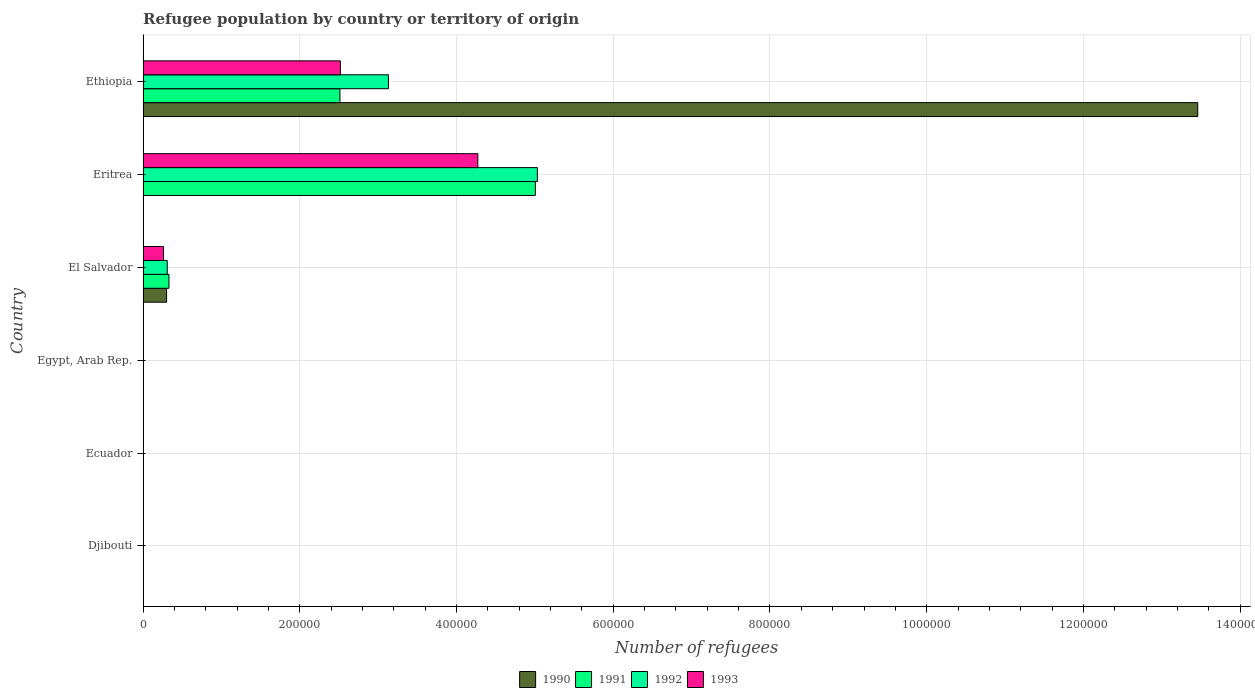Are the number of bars per tick equal to the number of legend labels?
Your answer should be very brief. Yes. Are the number of bars on each tick of the Y-axis equal?
Provide a short and direct response. Yes. How many bars are there on the 3rd tick from the top?
Offer a terse response. 4. How many bars are there on the 4th tick from the bottom?
Offer a terse response. 4. What is the label of the 1st group of bars from the top?
Offer a very short reply. Ethiopia. What is the number of refugees in 1992 in Egypt, Arab Rep.?
Provide a short and direct response. 209. Across all countries, what is the maximum number of refugees in 1990?
Make the answer very short. 1.35e+06. In which country was the number of refugees in 1993 maximum?
Your answer should be compact. Eritrea. In which country was the number of refugees in 1991 minimum?
Keep it short and to the point. Djibouti. What is the total number of refugees in 1993 in the graph?
Offer a terse response. 7.06e+05. What is the difference between the number of refugees in 1991 in Eritrea and that in Ethiopia?
Provide a succinct answer. 2.49e+05. What is the difference between the number of refugees in 1993 in Ecuador and the number of refugees in 1991 in El Salvador?
Your response must be concise. -3.30e+04. What is the average number of refugees in 1993 per country?
Offer a terse response. 1.18e+05. What is the difference between the number of refugees in 1990 and number of refugees in 1992 in El Salvador?
Make the answer very short. -836. What is the ratio of the number of refugees in 1993 in Egypt, Arab Rep. to that in El Salvador?
Make the answer very short. 0.01. What is the difference between the highest and the second highest number of refugees in 1992?
Offer a very short reply. 1.90e+05. What is the difference between the highest and the lowest number of refugees in 1992?
Provide a succinct answer. 5.03e+05. Is the sum of the number of refugees in 1992 in Egypt, Arab Rep. and Eritrea greater than the maximum number of refugees in 1990 across all countries?
Ensure brevity in your answer.  No. Is it the case that in every country, the sum of the number of refugees in 1993 and number of refugees in 1990 is greater than the sum of number of refugees in 1992 and number of refugees in 1991?
Your answer should be very brief. No. Is it the case that in every country, the sum of the number of refugees in 1993 and number of refugees in 1991 is greater than the number of refugees in 1990?
Offer a terse response. No. How many bars are there?
Provide a short and direct response. 24. Are all the bars in the graph horizontal?
Give a very brief answer. Yes. What is the difference between two consecutive major ticks on the X-axis?
Your answer should be very brief. 2.00e+05. Are the values on the major ticks of X-axis written in scientific E-notation?
Make the answer very short. No. Does the graph contain any zero values?
Ensure brevity in your answer.  No. Does the graph contain grids?
Provide a succinct answer. Yes. How many legend labels are there?
Give a very brief answer. 4. What is the title of the graph?
Provide a short and direct response. Refugee population by country or territory of origin. Does "2006" appear as one of the legend labels in the graph?
Provide a succinct answer. No. What is the label or title of the X-axis?
Ensure brevity in your answer.  Number of refugees. What is the label or title of the Y-axis?
Provide a short and direct response. Country. What is the Number of refugees of 1991 in Djibouti?
Make the answer very short. 10. What is the Number of refugees in 1992 in Ecuador?
Offer a terse response. 40. What is the Number of refugees of 1991 in Egypt, Arab Rep.?
Provide a succinct answer. 97. What is the Number of refugees of 1992 in Egypt, Arab Rep.?
Offer a very short reply. 209. What is the Number of refugees of 1993 in Egypt, Arab Rep.?
Your response must be concise. 258. What is the Number of refugees of 1990 in El Salvador?
Give a very brief answer. 3.00e+04. What is the Number of refugees of 1991 in El Salvador?
Offer a very short reply. 3.30e+04. What is the Number of refugees of 1992 in El Salvador?
Your answer should be very brief. 3.09e+04. What is the Number of refugees in 1993 in El Salvador?
Make the answer very short. 2.61e+04. What is the Number of refugees of 1990 in Eritrea?
Offer a terse response. 43. What is the Number of refugees of 1991 in Eritrea?
Provide a succinct answer. 5.01e+05. What is the Number of refugees of 1992 in Eritrea?
Make the answer very short. 5.03e+05. What is the Number of refugees in 1993 in Eritrea?
Your response must be concise. 4.27e+05. What is the Number of refugees in 1990 in Ethiopia?
Offer a terse response. 1.35e+06. What is the Number of refugees of 1991 in Ethiopia?
Your answer should be compact. 2.51e+05. What is the Number of refugees of 1992 in Ethiopia?
Your answer should be compact. 3.13e+05. What is the Number of refugees in 1993 in Ethiopia?
Provide a succinct answer. 2.52e+05. Across all countries, what is the maximum Number of refugees in 1990?
Your answer should be compact. 1.35e+06. Across all countries, what is the maximum Number of refugees in 1991?
Make the answer very short. 5.01e+05. Across all countries, what is the maximum Number of refugees of 1992?
Keep it short and to the point. 5.03e+05. Across all countries, what is the maximum Number of refugees in 1993?
Your answer should be compact. 4.27e+05. Across all countries, what is the minimum Number of refugees in 1990?
Provide a succinct answer. 3. Across all countries, what is the minimum Number of refugees of 1992?
Give a very brief answer. 11. Across all countries, what is the minimum Number of refugees in 1993?
Your response must be concise. 38. What is the total Number of refugees of 1990 in the graph?
Make the answer very short. 1.38e+06. What is the total Number of refugees of 1991 in the graph?
Ensure brevity in your answer.  7.85e+05. What is the total Number of refugees in 1992 in the graph?
Give a very brief answer. 8.47e+05. What is the total Number of refugees of 1993 in the graph?
Keep it short and to the point. 7.06e+05. What is the difference between the Number of refugees of 1990 in Djibouti and that in Ecuador?
Provide a short and direct response. 2. What is the difference between the Number of refugees of 1991 in Djibouti and that in Ecuador?
Your response must be concise. -17. What is the difference between the Number of refugees of 1992 in Djibouti and that in Ecuador?
Keep it short and to the point. -29. What is the difference between the Number of refugees in 1990 in Djibouti and that in Egypt, Arab Rep.?
Keep it short and to the point. -43. What is the difference between the Number of refugees in 1991 in Djibouti and that in Egypt, Arab Rep.?
Keep it short and to the point. -87. What is the difference between the Number of refugees of 1992 in Djibouti and that in Egypt, Arab Rep.?
Keep it short and to the point. -198. What is the difference between the Number of refugees in 1993 in Djibouti and that in Egypt, Arab Rep.?
Your answer should be compact. -220. What is the difference between the Number of refugees in 1990 in Djibouti and that in El Salvador?
Give a very brief answer. -3.00e+04. What is the difference between the Number of refugees in 1991 in Djibouti and that in El Salvador?
Keep it short and to the point. -3.30e+04. What is the difference between the Number of refugees of 1992 in Djibouti and that in El Salvador?
Ensure brevity in your answer.  -3.08e+04. What is the difference between the Number of refugees in 1993 in Djibouti and that in El Salvador?
Provide a short and direct response. -2.61e+04. What is the difference between the Number of refugees in 1990 in Djibouti and that in Eritrea?
Offer a very short reply. -38. What is the difference between the Number of refugees in 1991 in Djibouti and that in Eritrea?
Keep it short and to the point. -5.01e+05. What is the difference between the Number of refugees in 1992 in Djibouti and that in Eritrea?
Ensure brevity in your answer.  -5.03e+05. What is the difference between the Number of refugees in 1993 in Djibouti and that in Eritrea?
Give a very brief answer. -4.27e+05. What is the difference between the Number of refugees of 1990 in Djibouti and that in Ethiopia?
Your response must be concise. -1.35e+06. What is the difference between the Number of refugees in 1991 in Djibouti and that in Ethiopia?
Ensure brevity in your answer.  -2.51e+05. What is the difference between the Number of refugees in 1992 in Djibouti and that in Ethiopia?
Give a very brief answer. -3.13e+05. What is the difference between the Number of refugees in 1993 in Djibouti and that in Ethiopia?
Offer a very short reply. -2.52e+05. What is the difference between the Number of refugees in 1990 in Ecuador and that in Egypt, Arab Rep.?
Your response must be concise. -45. What is the difference between the Number of refugees of 1991 in Ecuador and that in Egypt, Arab Rep.?
Give a very brief answer. -70. What is the difference between the Number of refugees of 1992 in Ecuador and that in Egypt, Arab Rep.?
Your answer should be compact. -169. What is the difference between the Number of refugees in 1993 in Ecuador and that in Egypt, Arab Rep.?
Your answer should be very brief. -211. What is the difference between the Number of refugees of 1990 in Ecuador and that in El Salvador?
Keep it short and to the point. -3.00e+04. What is the difference between the Number of refugees in 1991 in Ecuador and that in El Salvador?
Offer a very short reply. -3.30e+04. What is the difference between the Number of refugees of 1992 in Ecuador and that in El Salvador?
Ensure brevity in your answer.  -3.08e+04. What is the difference between the Number of refugees of 1993 in Ecuador and that in El Salvador?
Provide a short and direct response. -2.61e+04. What is the difference between the Number of refugees in 1990 in Ecuador and that in Eritrea?
Provide a short and direct response. -40. What is the difference between the Number of refugees of 1991 in Ecuador and that in Eritrea?
Give a very brief answer. -5.01e+05. What is the difference between the Number of refugees in 1992 in Ecuador and that in Eritrea?
Your answer should be very brief. -5.03e+05. What is the difference between the Number of refugees of 1993 in Ecuador and that in Eritrea?
Provide a short and direct response. -4.27e+05. What is the difference between the Number of refugees of 1990 in Ecuador and that in Ethiopia?
Provide a short and direct response. -1.35e+06. What is the difference between the Number of refugees in 1991 in Ecuador and that in Ethiopia?
Keep it short and to the point. -2.51e+05. What is the difference between the Number of refugees in 1992 in Ecuador and that in Ethiopia?
Give a very brief answer. -3.13e+05. What is the difference between the Number of refugees of 1993 in Ecuador and that in Ethiopia?
Your response must be concise. -2.52e+05. What is the difference between the Number of refugees in 1990 in Egypt, Arab Rep. and that in El Salvador?
Provide a succinct answer. -3.00e+04. What is the difference between the Number of refugees of 1991 in Egypt, Arab Rep. and that in El Salvador?
Offer a very short reply. -3.30e+04. What is the difference between the Number of refugees in 1992 in Egypt, Arab Rep. and that in El Salvador?
Provide a succinct answer. -3.06e+04. What is the difference between the Number of refugees in 1993 in Egypt, Arab Rep. and that in El Salvador?
Offer a terse response. -2.59e+04. What is the difference between the Number of refugees in 1991 in Egypt, Arab Rep. and that in Eritrea?
Your response must be concise. -5.01e+05. What is the difference between the Number of refugees of 1992 in Egypt, Arab Rep. and that in Eritrea?
Give a very brief answer. -5.03e+05. What is the difference between the Number of refugees of 1993 in Egypt, Arab Rep. and that in Eritrea?
Provide a succinct answer. -4.27e+05. What is the difference between the Number of refugees of 1990 in Egypt, Arab Rep. and that in Ethiopia?
Provide a short and direct response. -1.35e+06. What is the difference between the Number of refugees of 1991 in Egypt, Arab Rep. and that in Ethiopia?
Ensure brevity in your answer.  -2.51e+05. What is the difference between the Number of refugees of 1992 in Egypt, Arab Rep. and that in Ethiopia?
Provide a succinct answer. -3.13e+05. What is the difference between the Number of refugees of 1993 in Egypt, Arab Rep. and that in Ethiopia?
Provide a short and direct response. -2.52e+05. What is the difference between the Number of refugees in 1990 in El Salvador and that in Eritrea?
Make the answer very short. 3.00e+04. What is the difference between the Number of refugees of 1991 in El Salvador and that in Eritrea?
Keep it short and to the point. -4.68e+05. What is the difference between the Number of refugees in 1992 in El Salvador and that in Eritrea?
Provide a short and direct response. -4.72e+05. What is the difference between the Number of refugees in 1993 in El Salvador and that in Eritrea?
Ensure brevity in your answer.  -4.01e+05. What is the difference between the Number of refugees of 1990 in El Salvador and that in Ethiopia?
Give a very brief answer. -1.32e+06. What is the difference between the Number of refugees of 1991 in El Salvador and that in Ethiopia?
Provide a succinct answer. -2.18e+05. What is the difference between the Number of refugees of 1992 in El Salvador and that in Ethiopia?
Provide a short and direct response. -2.82e+05. What is the difference between the Number of refugees of 1993 in El Salvador and that in Ethiopia?
Your response must be concise. -2.26e+05. What is the difference between the Number of refugees of 1990 in Eritrea and that in Ethiopia?
Offer a terse response. -1.35e+06. What is the difference between the Number of refugees of 1991 in Eritrea and that in Ethiopia?
Offer a terse response. 2.49e+05. What is the difference between the Number of refugees in 1992 in Eritrea and that in Ethiopia?
Ensure brevity in your answer.  1.90e+05. What is the difference between the Number of refugees of 1993 in Eritrea and that in Ethiopia?
Your response must be concise. 1.75e+05. What is the difference between the Number of refugees in 1990 in Djibouti and the Number of refugees in 1992 in Ecuador?
Offer a terse response. -35. What is the difference between the Number of refugees of 1990 in Djibouti and the Number of refugees of 1993 in Ecuador?
Your answer should be compact. -42. What is the difference between the Number of refugees in 1991 in Djibouti and the Number of refugees in 1992 in Ecuador?
Give a very brief answer. -30. What is the difference between the Number of refugees of 1991 in Djibouti and the Number of refugees of 1993 in Ecuador?
Provide a short and direct response. -37. What is the difference between the Number of refugees of 1992 in Djibouti and the Number of refugees of 1993 in Ecuador?
Your answer should be very brief. -36. What is the difference between the Number of refugees of 1990 in Djibouti and the Number of refugees of 1991 in Egypt, Arab Rep.?
Make the answer very short. -92. What is the difference between the Number of refugees of 1990 in Djibouti and the Number of refugees of 1992 in Egypt, Arab Rep.?
Your answer should be very brief. -204. What is the difference between the Number of refugees of 1990 in Djibouti and the Number of refugees of 1993 in Egypt, Arab Rep.?
Your answer should be compact. -253. What is the difference between the Number of refugees of 1991 in Djibouti and the Number of refugees of 1992 in Egypt, Arab Rep.?
Offer a very short reply. -199. What is the difference between the Number of refugees in 1991 in Djibouti and the Number of refugees in 1993 in Egypt, Arab Rep.?
Offer a very short reply. -248. What is the difference between the Number of refugees in 1992 in Djibouti and the Number of refugees in 1993 in Egypt, Arab Rep.?
Give a very brief answer. -247. What is the difference between the Number of refugees in 1990 in Djibouti and the Number of refugees in 1991 in El Salvador?
Provide a short and direct response. -3.30e+04. What is the difference between the Number of refugees in 1990 in Djibouti and the Number of refugees in 1992 in El Salvador?
Your answer should be very brief. -3.08e+04. What is the difference between the Number of refugees in 1990 in Djibouti and the Number of refugees in 1993 in El Salvador?
Your answer should be compact. -2.61e+04. What is the difference between the Number of refugees of 1991 in Djibouti and the Number of refugees of 1992 in El Salvador?
Your response must be concise. -3.08e+04. What is the difference between the Number of refugees in 1991 in Djibouti and the Number of refugees in 1993 in El Salvador?
Give a very brief answer. -2.61e+04. What is the difference between the Number of refugees in 1992 in Djibouti and the Number of refugees in 1993 in El Salvador?
Give a very brief answer. -2.61e+04. What is the difference between the Number of refugees in 1990 in Djibouti and the Number of refugees in 1991 in Eritrea?
Your answer should be compact. -5.01e+05. What is the difference between the Number of refugees in 1990 in Djibouti and the Number of refugees in 1992 in Eritrea?
Keep it short and to the point. -5.03e+05. What is the difference between the Number of refugees of 1990 in Djibouti and the Number of refugees of 1993 in Eritrea?
Make the answer very short. -4.27e+05. What is the difference between the Number of refugees in 1991 in Djibouti and the Number of refugees in 1992 in Eritrea?
Provide a short and direct response. -5.03e+05. What is the difference between the Number of refugees in 1991 in Djibouti and the Number of refugees in 1993 in Eritrea?
Your answer should be compact. -4.27e+05. What is the difference between the Number of refugees in 1992 in Djibouti and the Number of refugees in 1993 in Eritrea?
Provide a succinct answer. -4.27e+05. What is the difference between the Number of refugees of 1990 in Djibouti and the Number of refugees of 1991 in Ethiopia?
Your response must be concise. -2.51e+05. What is the difference between the Number of refugees in 1990 in Djibouti and the Number of refugees in 1992 in Ethiopia?
Keep it short and to the point. -3.13e+05. What is the difference between the Number of refugees of 1990 in Djibouti and the Number of refugees of 1993 in Ethiopia?
Give a very brief answer. -2.52e+05. What is the difference between the Number of refugees of 1991 in Djibouti and the Number of refugees of 1992 in Ethiopia?
Offer a terse response. -3.13e+05. What is the difference between the Number of refugees of 1991 in Djibouti and the Number of refugees of 1993 in Ethiopia?
Make the answer very short. -2.52e+05. What is the difference between the Number of refugees of 1992 in Djibouti and the Number of refugees of 1993 in Ethiopia?
Ensure brevity in your answer.  -2.52e+05. What is the difference between the Number of refugees in 1990 in Ecuador and the Number of refugees in 1991 in Egypt, Arab Rep.?
Provide a short and direct response. -94. What is the difference between the Number of refugees in 1990 in Ecuador and the Number of refugees in 1992 in Egypt, Arab Rep.?
Your answer should be compact. -206. What is the difference between the Number of refugees in 1990 in Ecuador and the Number of refugees in 1993 in Egypt, Arab Rep.?
Your answer should be compact. -255. What is the difference between the Number of refugees of 1991 in Ecuador and the Number of refugees of 1992 in Egypt, Arab Rep.?
Your answer should be very brief. -182. What is the difference between the Number of refugees in 1991 in Ecuador and the Number of refugees in 1993 in Egypt, Arab Rep.?
Make the answer very short. -231. What is the difference between the Number of refugees of 1992 in Ecuador and the Number of refugees of 1993 in Egypt, Arab Rep.?
Your response must be concise. -218. What is the difference between the Number of refugees of 1990 in Ecuador and the Number of refugees of 1991 in El Salvador?
Ensure brevity in your answer.  -3.30e+04. What is the difference between the Number of refugees of 1990 in Ecuador and the Number of refugees of 1992 in El Salvador?
Offer a very short reply. -3.09e+04. What is the difference between the Number of refugees of 1990 in Ecuador and the Number of refugees of 1993 in El Salvador?
Your response must be concise. -2.61e+04. What is the difference between the Number of refugees in 1991 in Ecuador and the Number of refugees in 1992 in El Salvador?
Offer a very short reply. -3.08e+04. What is the difference between the Number of refugees of 1991 in Ecuador and the Number of refugees of 1993 in El Salvador?
Ensure brevity in your answer.  -2.61e+04. What is the difference between the Number of refugees of 1992 in Ecuador and the Number of refugees of 1993 in El Salvador?
Give a very brief answer. -2.61e+04. What is the difference between the Number of refugees in 1990 in Ecuador and the Number of refugees in 1991 in Eritrea?
Your answer should be compact. -5.01e+05. What is the difference between the Number of refugees in 1990 in Ecuador and the Number of refugees in 1992 in Eritrea?
Provide a short and direct response. -5.03e+05. What is the difference between the Number of refugees of 1990 in Ecuador and the Number of refugees of 1993 in Eritrea?
Provide a succinct answer. -4.27e+05. What is the difference between the Number of refugees of 1991 in Ecuador and the Number of refugees of 1992 in Eritrea?
Your answer should be very brief. -5.03e+05. What is the difference between the Number of refugees in 1991 in Ecuador and the Number of refugees in 1993 in Eritrea?
Your answer should be very brief. -4.27e+05. What is the difference between the Number of refugees in 1992 in Ecuador and the Number of refugees in 1993 in Eritrea?
Your response must be concise. -4.27e+05. What is the difference between the Number of refugees of 1990 in Ecuador and the Number of refugees of 1991 in Ethiopia?
Offer a terse response. -2.51e+05. What is the difference between the Number of refugees of 1990 in Ecuador and the Number of refugees of 1992 in Ethiopia?
Provide a short and direct response. -3.13e+05. What is the difference between the Number of refugees in 1990 in Ecuador and the Number of refugees in 1993 in Ethiopia?
Make the answer very short. -2.52e+05. What is the difference between the Number of refugees in 1991 in Ecuador and the Number of refugees in 1992 in Ethiopia?
Provide a succinct answer. -3.13e+05. What is the difference between the Number of refugees of 1991 in Ecuador and the Number of refugees of 1993 in Ethiopia?
Offer a terse response. -2.52e+05. What is the difference between the Number of refugees in 1992 in Ecuador and the Number of refugees in 1993 in Ethiopia?
Offer a very short reply. -2.52e+05. What is the difference between the Number of refugees in 1990 in Egypt, Arab Rep. and the Number of refugees in 1991 in El Salvador?
Offer a very short reply. -3.30e+04. What is the difference between the Number of refugees in 1990 in Egypt, Arab Rep. and the Number of refugees in 1992 in El Salvador?
Offer a very short reply. -3.08e+04. What is the difference between the Number of refugees of 1990 in Egypt, Arab Rep. and the Number of refugees of 1993 in El Salvador?
Your answer should be very brief. -2.61e+04. What is the difference between the Number of refugees of 1991 in Egypt, Arab Rep. and the Number of refugees of 1992 in El Salvador?
Your answer should be compact. -3.08e+04. What is the difference between the Number of refugees in 1991 in Egypt, Arab Rep. and the Number of refugees in 1993 in El Salvador?
Give a very brief answer. -2.60e+04. What is the difference between the Number of refugees in 1992 in Egypt, Arab Rep. and the Number of refugees in 1993 in El Salvador?
Provide a short and direct response. -2.59e+04. What is the difference between the Number of refugees in 1990 in Egypt, Arab Rep. and the Number of refugees in 1991 in Eritrea?
Provide a succinct answer. -5.01e+05. What is the difference between the Number of refugees of 1990 in Egypt, Arab Rep. and the Number of refugees of 1992 in Eritrea?
Offer a terse response. -5.03e+05. What is the difference between the Number of refugees in 1990 in Egypt, Arab Rep. and the Number of refugees in 1993 in Eritrea?
Ensure brevity in your answer.  -4.27e+05. What is the difference between the Number of refugees of 1991 in Egypt, Arab Rep. and the Number of refugees of 1992 in Eritrea?
Offer a terse response. -5.03e+05. What is the difference between the Number of refugees in 1991 in Egypt, Arab Rep. and the Number of refugees in 1993 in Eritrea?
Keep it short and to the point. -4.27e+05. What is the difference between the Number of refugees of 1992 in Egypt, Arab Rep. and the Number of refugees of 1993 in Eritrea?
Your answer should be very brief. -4.27e+05. What is the difference between the Number of refugees of 1990 in Egypt, Arab Rep. and the Number of refugees of 1991 in Ethiopia?
Give a very brief answer. -2.51e+05. What is the difference between the Number of refugees of 1990 in Egypt, Arab Rep. and the Number of refugees of 1992 in Ethiopia?
Provide a succinct answer. -3.13e+05. What is the difference between the Number of refugees in 1990 in Egypt, Arab Rep. and the Number of refugees in 1993 in Ethiopia?
Make the answer very short. -2.52e+05. What is the difference between the Number of refugees of 1991 in Egypt, Arab Rep. and the Number of refugees of 1992 in Ethiopia?
Provide a short and direct response. -3.13e+05. What is the difference between the Number of refugees of 1991 in Egypt, Arab Rep. and the Number of refugees of 1993 in Ethiopia?
Your response must be concise. -2.52e+05. What is the difference between the Number of refugees in 1992 in Egypt, Arab Rep. and the Number of refugees in 1993 in Ethiopia?
Offer a very short reply. -2.52e+05. What is the difference between the Number of refugees of 1990 in El Salvador and the Number of refugees of 1991 in Eritrea?
Provide a short and direct response. -4.71e+05. What is the difference between the Number of refugees in 1990 in El Salvador and the Number of refugees in 1992 in Eritrea?
Ensure brevity in your answer.  -4.73e+05. What is the difference between the Number of refugees of 1990 in El Salvador and the Number of refugees of 1993 in Eritrea?
Keep it short and to the point. -3.97e+05. What is the difference between the Number of refugees of 1991 in El Salvador and the Number of refugees of 1992 in Eritrea?
Provide a short and direct response. -4.70e+05. What is the difference between the Number of refugees in 1991 in El Salvador and the Number of refugees in 1993 in Eritrea?
Offer a terse response. -3.94e+05. What is the difference between the Number of refugees of 1992 in El Salvador and the Number of refugees of 1993 in Eritrea?
Your answer should be very brief. -3.96e+05. What is the difference between the Number of refugees of 1990 in El Salvador and the Number of refugees of 1991 in Ethiopia?
Offer a very short reply. -2.21e+05. What is the difference between the Number of refugees in 1990 in El Salvador and the Number of refugees in 1992 in Ethiopia?
Offer a terse response. -2.83e+05. What is the difference between the Number of refugees in 1990 in El Salvador and the Number of refugees in 1993 in Ethiopia?
Offer a terse response. -2.22e+05. What is the difference between the Number of refugees of 1991 in El Salvador and the Number of refugees of 1992 in Ethiopia?
Offer a very short reply. -2.80e+05. What is the difference between the Number of refugees in 1991 in El Salvador and the Number of refugees in 1993 in Ethiopia?
Make the answer very short. -2.19e+05. What is the difference between the Number of refugees in 1992 in El Salvador and the Number of refugees in 1993 in Ethiopia?
Your answer should be compact. -2.21e+05. What is the difference between the Number of refugees of 1990 in Eritrea and the Number of refugees of 1991 in Ethiopia?
Offer a very short reply. -2.51e+05. What is the difference between the Number of refugees in 1990 in Eritrea and the Number of refugees in 1992 in Ethiopia?
Give a very brief answer. -3.13e+05. What is the difference between the Number of refugees in 1990 in Eritrea and the Number of refugees in 1993 in Ethiopia?
Keep it short and to the point. -2.52e+05. What is the difference between the Number of refugees of 1991 in Eritrea and the Number of refugees of 1992 in Ethiopia?
Keep it short and to the point. 1.88e+05. What is the difference between the Number of refugees in 1991 in Eritrea and the Number of refugees in 1993 in Ethiopia?
Provide a succinct answer. 2.49e+05. What is the difference between the Number of refugees of 1992 in Eritrea and the Number of refugees of 1993 in Ethiopia?
Provide a short and direct response. 2.51e+05. What is the average Number of refugees in 1990 per country?
Offer a terse response. 2.29e+05. What is the average Number of refugees of 1991 per country?
Your answer should be very brief. 1.31e+05. What is the average Number of refugees in 1992 per country?
Offer a very short reply. 1.41e+05. What is the average Number of refugees of 1993 per country?
Your answer should be very brief. 1.18e+05. What is the difference between the Number of refugees of 1990 and Number of refugees of 1992 in Djibouti?
Provide a succinct answer. -6. What is the difference between the Number of refugees of 1990 and Number of refugees of 1993 in Djibouti?
Offer a very short reply. -33. What is the difference between the Number of refugees of 1991 and Number of refugees of 1992 in Djibouti?
Provide a succinct answer. -1. What is the difference between the Number of refugees in 1992 and Number of refugees in 1993 in Djibouti?
Offer a very short reply. -27. What is the difference between the Number of refugees of 1990 and Number of refugees of 1992 in Ecuador?
Offer a terse response. -37. What is the difference between the Number of refugees of 1990 and Number of refugees of 1993 in Ecuador?
Keep it short and to the point. -44. What is the difference between the Number of refugees of 1991 and Number of refugees of 1992 in Ecuador?
Offer a terse response. -13. What is the difference between the Number of refugees in 1991 and Number of refugees in 1993 in Ecuador?
Keep it short and to the point. -20. What is the difference between the Number of refugees in 1992 and Number of refugees in 1993 in Ecuador?
Keep it short and to the point. -7. What is the difference between the Number of refugees in 1990 and Number of refugees in 1991 in Egypt, Arab Rep.?
Provide a short and direct response. -49. What is the difference between the Number of refugees of 1990 and Number of refugees of 1992 in Egypt, Arab Rep.?
Offer a terse response. -161. What is the difference between the Number of refugees in 1990 and Number of refugees in 1993 in Egypt, Arab Rep.?
Keep it short and to the point. -210. What is the difference between the Number of refugees of 1991 and Number of refugees of 1992 in Egypt, Arab Rep.?
Give a very brief answer. -112. What is the difference between the Number of refugees in 1991 and Number of refugees in 1993 in Egypt, Arab Rep.?
Keep it short and to the point. -161. What is the difference between the Number of refugees of 1992 and Number of refugees of 1993 in Egypt, Arab Rep.?
Your response must be concise. -49. What is the difference between the Number of refugees of 1990 and Number of refugees of 1991 in El Salvador?
Provide a short and direct response. -3030. What is the difference between the Number of refugees in 1990 and Number of refugees in 1992 in El Salvador?
Make the answer very short. -836. What is the difference between the Number of refugees in 1990 and Number of refugees in 1993 in El Salvador?
Offer a very short reply. 3895. What is the difference between the Number of refugees in 1991 and Number of refugees in 1992 in El Salvador?
Offer a very short reply. 2194. What is the difference between the Number of refugees of 1991 and Number of refugees of 1993 in El Salvador?
Offer a terse response. 6925. What is the difference between the Number of refugees in 1992 and Number of refugees in 1993 in El Salvador?
Your answer should be compact. 4731. What is the difference between the Number of refugees in 1990 and Number of refugees in 1991 in Eritrea?
Your answer should be very brief. -5.01e+05. What is the difference between the Number of refugees in 1990 and Number of refugees in 1992 in Eritrea?
Provide a short and direct response. -5.03e+05. What is the difference between the Number of refugees in 1990 and Number of refugees in 1993 in Eritrea?
Make the answer very short. -4.27e+05. What is the difference between the Number of refugees of 1991 and Number of refugees of 1992 in Eritrea?
Make the answer very short. -2567. What is the difference between the Number of refugees of 1991 and Number of refugees of 1993 in Eritrea?
Your response must be concise. 7.34e+04. What is the difference between the Number of refugees in 1992 and Number of refugees in 1993 in Eritrea?
Give a very brief answer. 7.60e+04. What is the difference between the Number of refugees of 1990 and Number of refugees of 1991 in Ethiopia?
Offer a very short reply. 1.09e+06. What is the difference between the Number of refugees of 1990 and Number of refugees of 1992 in Ethiopia?
Your answer should be compact. 1.03e+06. What is the difference between the Number of refugees in 1990 and Number of refugees in 1993 in Ethiopia?
Offer a terse response. 1.09e+06. What is the difference between the Number of refugees in 1991 and Number of refugees in 1992 in Ethiopia?
Your answer should be compact. -6.19e+04. What is the difference between the Number of refugees in 1991 and Number of refugees in 1993 in Ethiopia?
Your response must be concise. -587. What is the difference between the Number of refugees of 1992 and Number of refugees of 1993 in Ethiopia?
Give a very brief answer. 6.13e+04. What is the ratio of the Number of refugees in 1991 in Djibouti to that in Ecuador?
Keep it short and to the point. 0.37. What is the ratio of the Number of refugees of 1992 in Djibouti to that in Ecuador?
Keep it short and to the point. 0.28. What is the ratio of the Number of refugees in 1993 in Djibouti to that in Ecuador?
Make the answer very short. 0.81. What is the ratio of the Number of refugees in 1990 in Djibouti to that in Egypt, Arab Rep.?
Keep it short and to the point. 0.1. What is the ratio of the Number of refugees in 1991 in Djibouti to that in Egypt, Arab Rep.?
Your answer should be compact. 0.1. What is the ratio of the Number of refugees in 1992 in Djibouti to that in Egypt, Arab Rep.?
Provide a short and direct response. 0.05. What is the ratio of the Number of refugees in 1993 in Djibouti to that in Egypt, Arab Rep.?
Offer a very short reply. 0.15. What is the ratio of the Number of refugees of 1992 in Djibouti to that in El Salvador?
Offer a very short reply. 0. What is the ratio of the Number of refugees in 1993 in Djibouti to that in El Salvador?
Your response must be concise. 0. What is the ratio of the Number of refugees in 1990 in Djibouti to that in Eritrea?
Your answer should be very brief. 0.12. What is the ratio of the Number of refugees of 1991 in Djibouti to that in Eritrea?
Your answer should be very brief. 0. What is the ratio of the Number of refugees in 1992 in Djibouti to that in Ethiopia?
Provide a succinct answer. 0. What is the ratio of the Number of refugees in 1993 in Djibouti to that in Ethiopia?
Keep it short and to the point. 0. What is the ratio of the Number of refugees of 1990 in Ecuador to that in Egypt, Arab Rep.?
Offer a terse response. 0.06. What is the ratio of the Number of refugees in 1991 in Ecuador to that in Egypt, Arab Rep.?
Make the answer very short. 0.28. What is the ratio of the Number of refugees in 1992 in Ecuador to that in Egypt, Arab Rep.?
Your response must be concise. 0.19. What is the ratio of the Number of refugees of 1993 in Ecuador to that in Egypt, Arab Rep.?
Your answer should be compact. 0.18. What is the ratio of the Number of refugees of 1991 in Ecuador to that in El Salvador?
Provide a short and direct response. 0. What is the ratio of the Number of refugees of 1992 in Ecuador to that in El Salvador?
Make the answer very short. 0. What is the ratio of the Number of refugees of 1993 in Ecuador to that in El Salvador?
Make the answer very short. 0. What is the ratio of the Number of refugees in 1990 in Ecuador to that in Eritrea?
Make the answer very short. 0.07. What is the ratio of the Number of refugees of 1991 in Ecuador to that in Eritrea?
Your answer should be very brief. 0. What is the ratio of the Number of refugees of 1992 in Ecuador to that in Eritrea?
Your answer should be compact. 0. What is the ratio of the Number of refugees of 1993 in Ecuador to that in Eritrea?
Your answer should be compact. 0. What is the ratio of the Number of refugees in 1990 in Ecuador to that in Ethiopia?
Your answer should be compact. 0. What is the ratio of the Number of refugees of 1992 in Ecuador to that in Ethiopia?
Your answer should be compact. 0. What is the ratio of the Number of refugees in 1990 in Egypt, Arab Rep. to that in El Salvador?
Offer a very short reply. 0. What is the ratio of the Number of refugees of 1991 in Egypt, Arab Rep. to that in El Salvador?
Offer a terse response. 0. What is the ratio of the Number of refugees of 1992 in Egypt, Arab Rep. to that in El Salvador?
Make the answer very short. 0.01. What is the ratio of the Number of refugees of 1993 in Egypt, Arab Rep. to that in El Salvador?
Your response must be concise. 0.01. What is the ratio of the Number of refugees of 1990 in Egypt, Arab Rep. to that in Eritrea?
Make the answer very short. 1.12. What is the ratio of the Number of refugees in 1991 in Egypt, Arab Rep. to that in Eritrea?
Ensure brevity in your answer.  0. What is the ratio of the Number of refugees in 1993 in Egypt, Arab Rep. to that in Eritrea?
Make the answer very short. 0. What is the ratio of the Number of refugees of 1992 in Egypt, Arab Rep. to that in Ethiopia?
Keep it short and to the point. 0. What is the ratio of the Number of refugees of 1993 in Egypt, Arab Rep. to that in Ethiopia?
Offer a very short reply. 0. What is the ratio of the Number of refugees of 1990 in El Salvador to that in Eritrea?
Keep it short and to the point. 698.12. What is the ratio of the Number of refugees in 1991 in El Salvador to that in Eritrea?
Offer a very short reply. 0.07. What is the ratio of the Number of refugees in 1992 in El Salvador to that in Eritrea?
Offer a very short reply. 0.06. What is the ratio of the Number of refugees of 1993 in El Salvador to that in Eritrea?
Your answer should be compact. 0.06. What is the ratio of the Number of refugees in 1990 in El Salvador to that in Ethiopia?
Your answer should be compact. 0.02. What is the ratio of the Number of refugees of 1991 in El Salvador to that in Ethiopia?
Give a very brief answer. 0.13. What is the ratio of the Number of refugees in 1992 in El Salvador to that in Ethiopia?
Your answer should be very brief. 0.1. What is the ratio of the Number of refugees of 1993 in El Salvador to that in Ethiopia?
Offer a very short reply. 0.1. What is the ratio of the Number of refugees of 1991 in Eritrea to that in Ethiopia?
Ensure brevity in your answer.  1.99. What is the ratio of the Number of refugees in 1992 in Eritrea to that in Ethiopia?
Ensure brevity in your answer.  1.61. What is the ratio of the Number of refugees in 1993 in Eritrea to that in Ethiopia?
Your answer should be compact. 1.7. What is the difference between the highest and the second highest Number of refugees of 1990?
Your answer should be very brief. 1.32e+06. What is the difference between the highest and the second highest Number of refugees of 1991?
Offer a very short reply. 2.49e+05. What is the difference between the highest and the second highest Number of refugees in 1992?
Offer a terse response. 1.90e+05. What is the difference between the highest and the second highest Number of refugees in 1993?
Provide a short and direct response. 1.75e+05. What is the difference between the highest and the lowest Number of refugees of 1990?
Offer a terse response. 1.35e+06. What is the difference between the highest and the lowest Number of refugees of 1991?
Provide a succinct answer. 5.01e+05. What is the difference between the highest and the lowest Number of refugees of 1992?
Your response must be concise. 5.03e+05. What is the difference between the highest and the lowest Number of refugees in 1993?
Offer a terse response. 4.27e+05. 